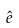Convert formula to latex. <formula><loc_0><loc_0><loc_500><loc_500>\hat { e }</formula> 